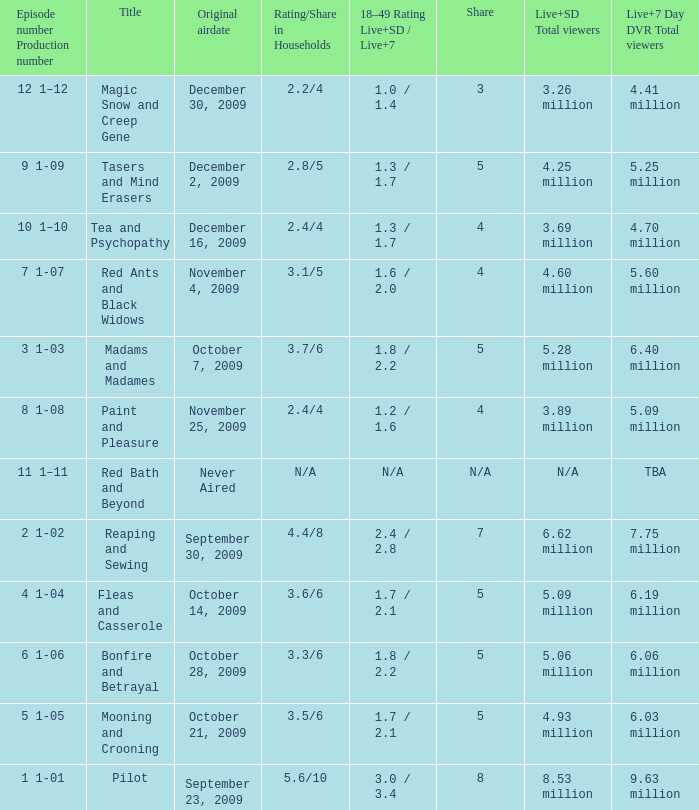What are the "18–49 Rating Live+SD" ratings and "Live+7" ratings, respectively, for the episode that originally aired on October 14, 2009? 1.7 / 2.1. 